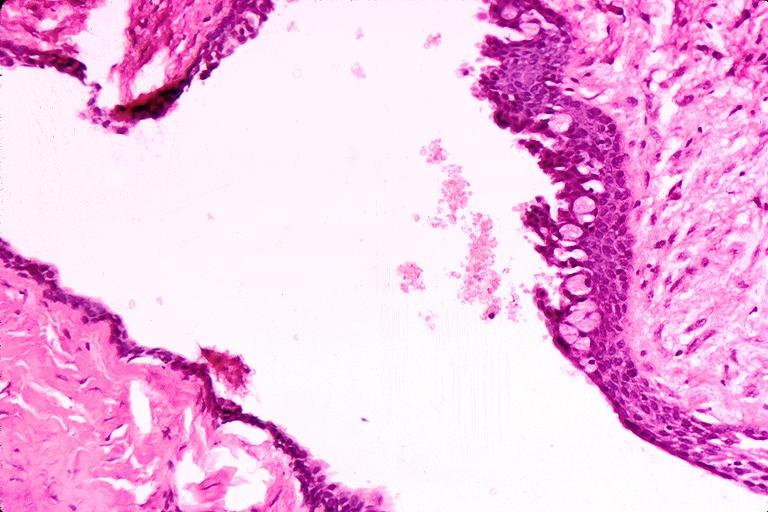what is present?
Answer the question using a single word or phrase. Oral 